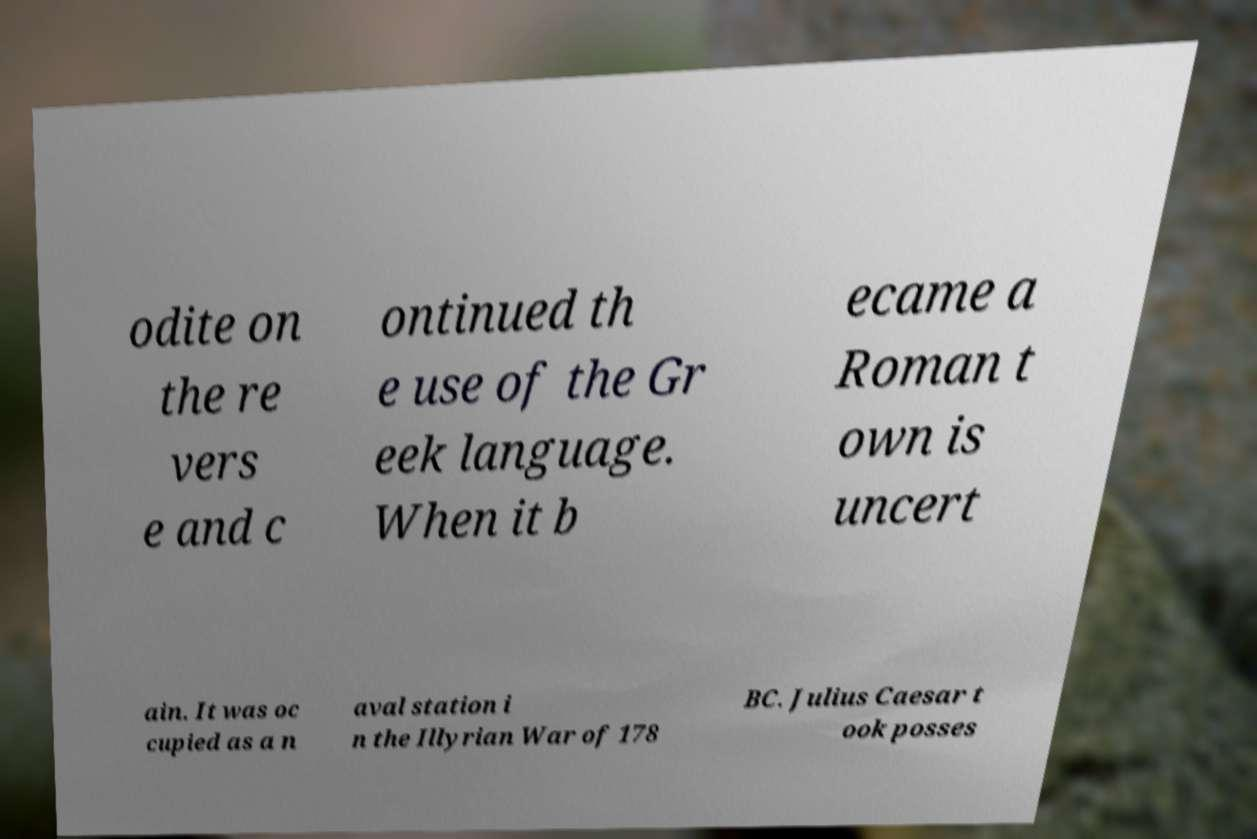Can you read and provide the text displayed in the image?This photo seems to have some interesting text. Can you extract and type it out for me? odite on the re vers e and c ontinued th e use of the Gr eek language. When it b ecame a Roman t own is uncert ain. It was oc cupied as a n aval station i n the Illyrian War of 178 BC. Julius Caesar t ook posses 